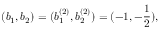Convert formula to latex. <formula><loc_0><loc_0><loc_500><loc_500>( b _ { 1 } , b _ { 2 } ) = ( b _ { 1 } ^ { ( 2 ) } , b _ { 2 } ^ { ( 2 ) } ) = ( - 1 , - \frac { 1 } { 2 } ) ,</formula> 